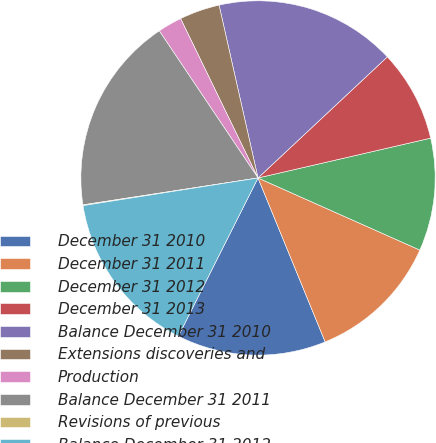<chart> <loc_0><loc_0><loc_500><loc_500><pie_chart><fcel>December 31 2010<fcel>December 31 2011<fcel>December 31 2012<fcel>December 31 2013<fcel>Balance December 31 2010<fcel>Extensions discoveries and<fcel>Production<fcel>Balance December 31 2011<fcel>Revisions of previous<fcel>Balance December 31 2012<nl><fcel>13.61%<fcel>12.14%<fcel>10.28%<fcel>8.37%<fcel>16.55%<fcel>3.67%<fcel>2.21%<fcel>18.02%<fcel>0.07%<fcel>15.08%<nl></chart> 